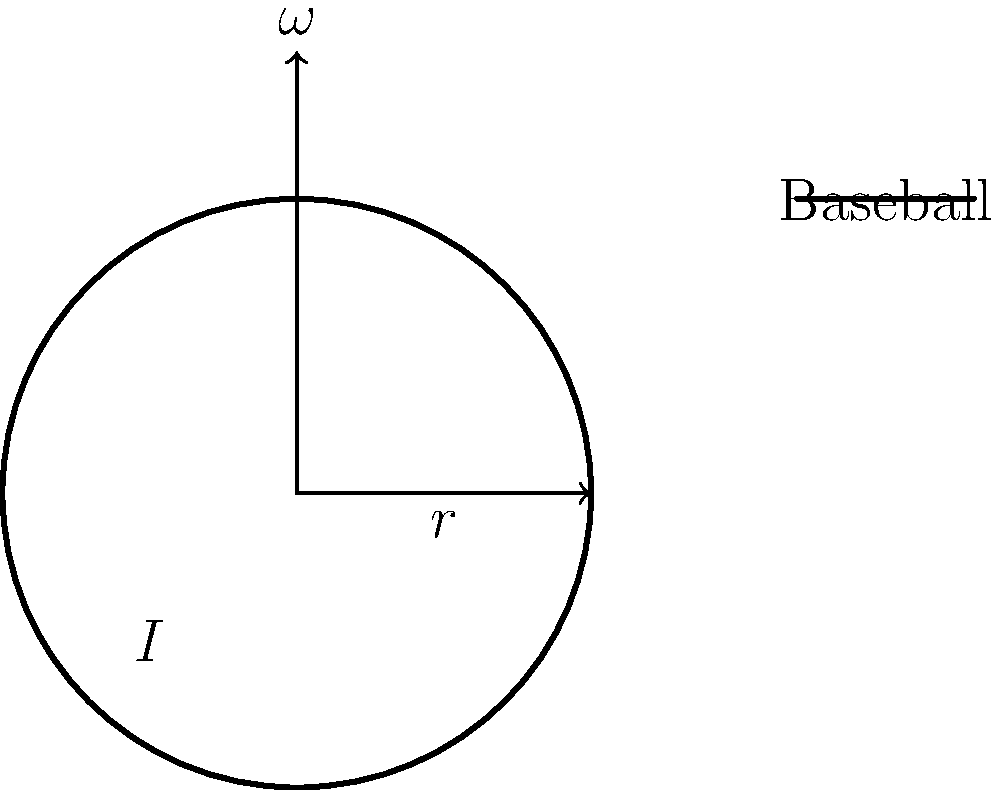In a thrilling game at Hank Aaron Stadium, a pitcher throws a curveball with a radius of 3.7 cm and a mass of 145 grams. If the ball is spinning at 1800 rpm when it leaves the pitcher's hand, what is its angular momentum? Assume the baseball can be treated as a solid sphere. Let's approach this step-by-step, using the formula for angular momentum: $L = I\omega$

1) First, we need to calculate the moment of inertia (I) for a solid sphere:
   $I = \frac{2}{5}mr^2$
   where m is the mass and r is the radius.

2) Convert our given values to SI units:
   Mass (m) = 145 g = 0.145 kg
   Radius (r) = 3.7 cm = 0.037 m

3) Calculate the moment of inertia:
   $I = \frac{2}{5} \times 0.145 \text{ kg} \times (0.037 \text{ m})^2 = 1.58 \times 10^{-5} \text{ kg·m}^2$

4) Convert angular velocity from rpm to rad/s:
   $\omega = 1800 \text{ rpm} \times \frac{2\pi \text{ rad}}{1 \text{ revolution}} \times \frac{1 \text{ minute}}{60 \text{ seconds}} = 188.5 \text{ rad/s}$

5) Now we can calculate the angular momentum:
   $L = I\omega = 1.58 \times 10^{-5} \text{ kg·m}^2 \times 188.5 \text{ rad/s} = 2.98 \times 10^{-3} \text{ kg·m}^2/s$

Therefore, the angular momentum of the baseball is approximately $2.98 \times 10^{-3} \text{ kg·m}^2/s$.
Answer: $2.98 \times 10^{-3} \text{ kg·m}^2/s$ 